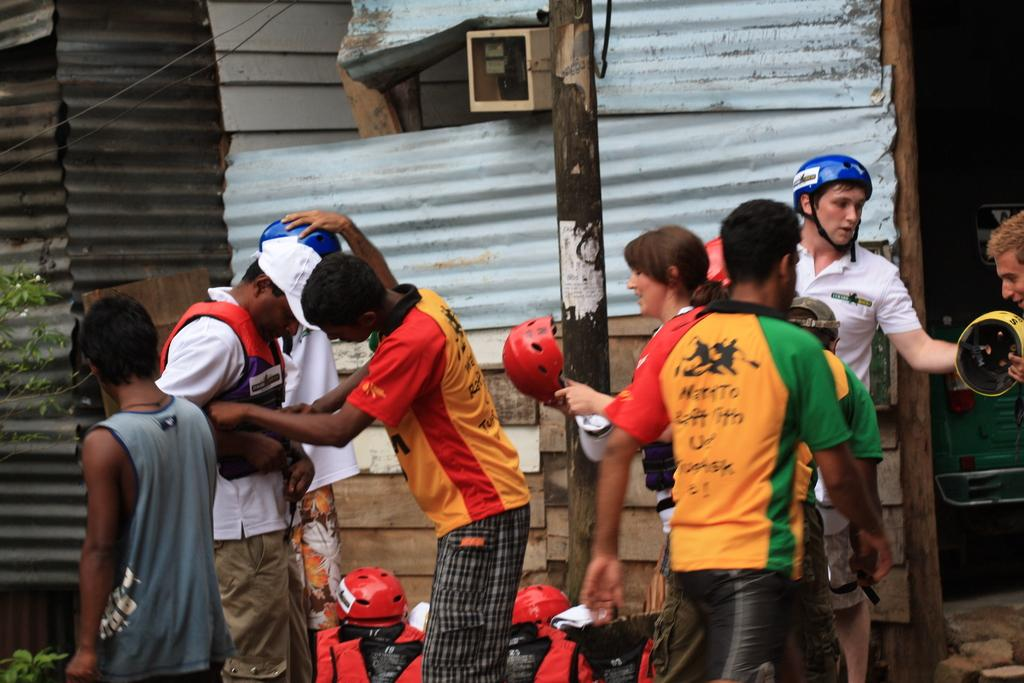How many people are in the image? There is a group of people in the image, but the exact number is not specified. What are the people standing in front of? The people are standing in front of roofing sheets. What is located beside the group of people? There is a pole beside the group of people. What type of protective gear is present in front of the pole? Red helmets are present in front of the pole. What color is the paint on the bike in the image? There is no bike present in the image, so there is no paint to describe. Is the scene taking place during the night in the image? The time of day is not specified in the image, so it cannot be determined if it is night or not. 